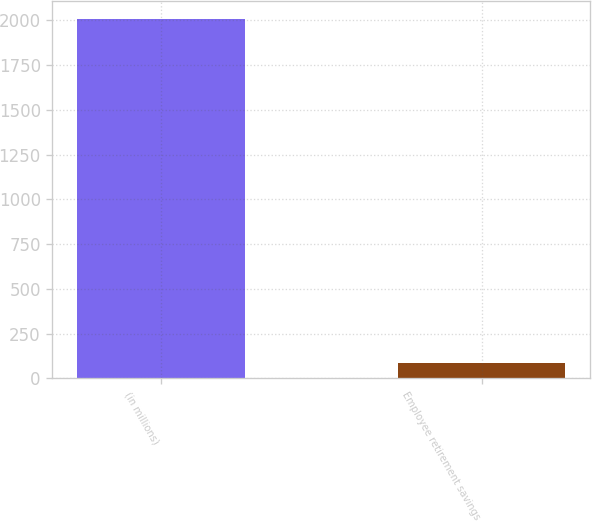Convert chart to OTSL. <chart><loc_0><loc_0><loc_500><loc_500><bar_chart><fcel>(in millions)<fcel>Employee retirement savings<nl><fcel>2010<fcel>84.3<nl></chart> 